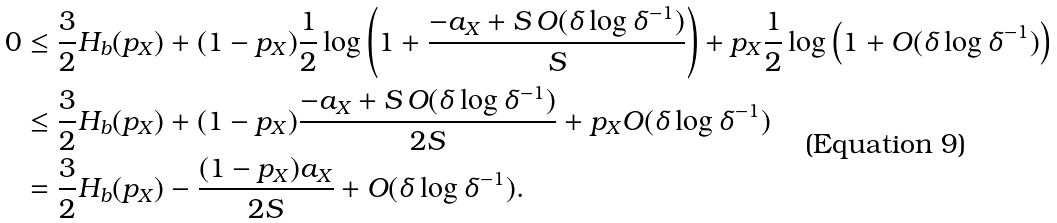<formula> <loc_0><loc_0><loc_500><loc_500>0 & \leq \frac { 3 } { 2 } H _ { b } ( p _ { X } ) + ( 1 - p _ { X } ) \frac { 1 } { 2 } \log \left ( 1 + \frac { - a _ { X } + S \, O ( \delta \log \delta ^ { - 1 } ) } { S } \right ) + p _ { X } \frac { 1 } { 2 } \log \left ( 1 + O ( \delta \log \delta ^ { - 1 } ) \right ) \\ & \leq \frac { 3 } { 2 } H _ { b } ( p _ { X } ) + ( 1 - p _ { X } ) \frac { - a _ { X } + S \, O ( \delta \log \delta ^ { - 1 } ) } { 2 S } + p _ { X } O ( \delta \log \delta ^ { - 1 } ) \\ & = \frac { 3 } { 2 } H _ { b } ( p _ { X } ) - \frac { ( 1 - p _ { X } ) a _ { X } } { 2 S } + O ( \delta \log \delta ^ { - 1 } ) .</formula> 